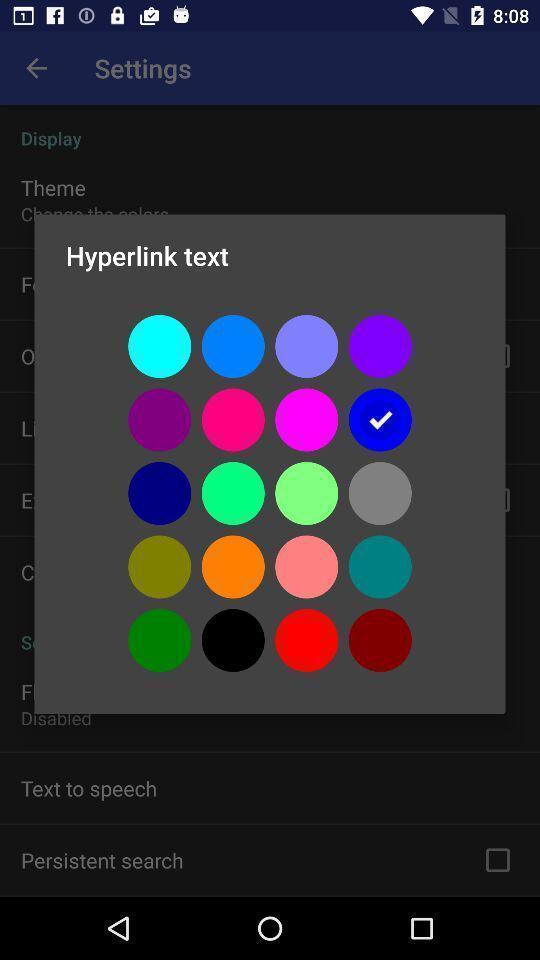Provide a detailed account of this screenshot. Pop-up displaying various colors for text. 